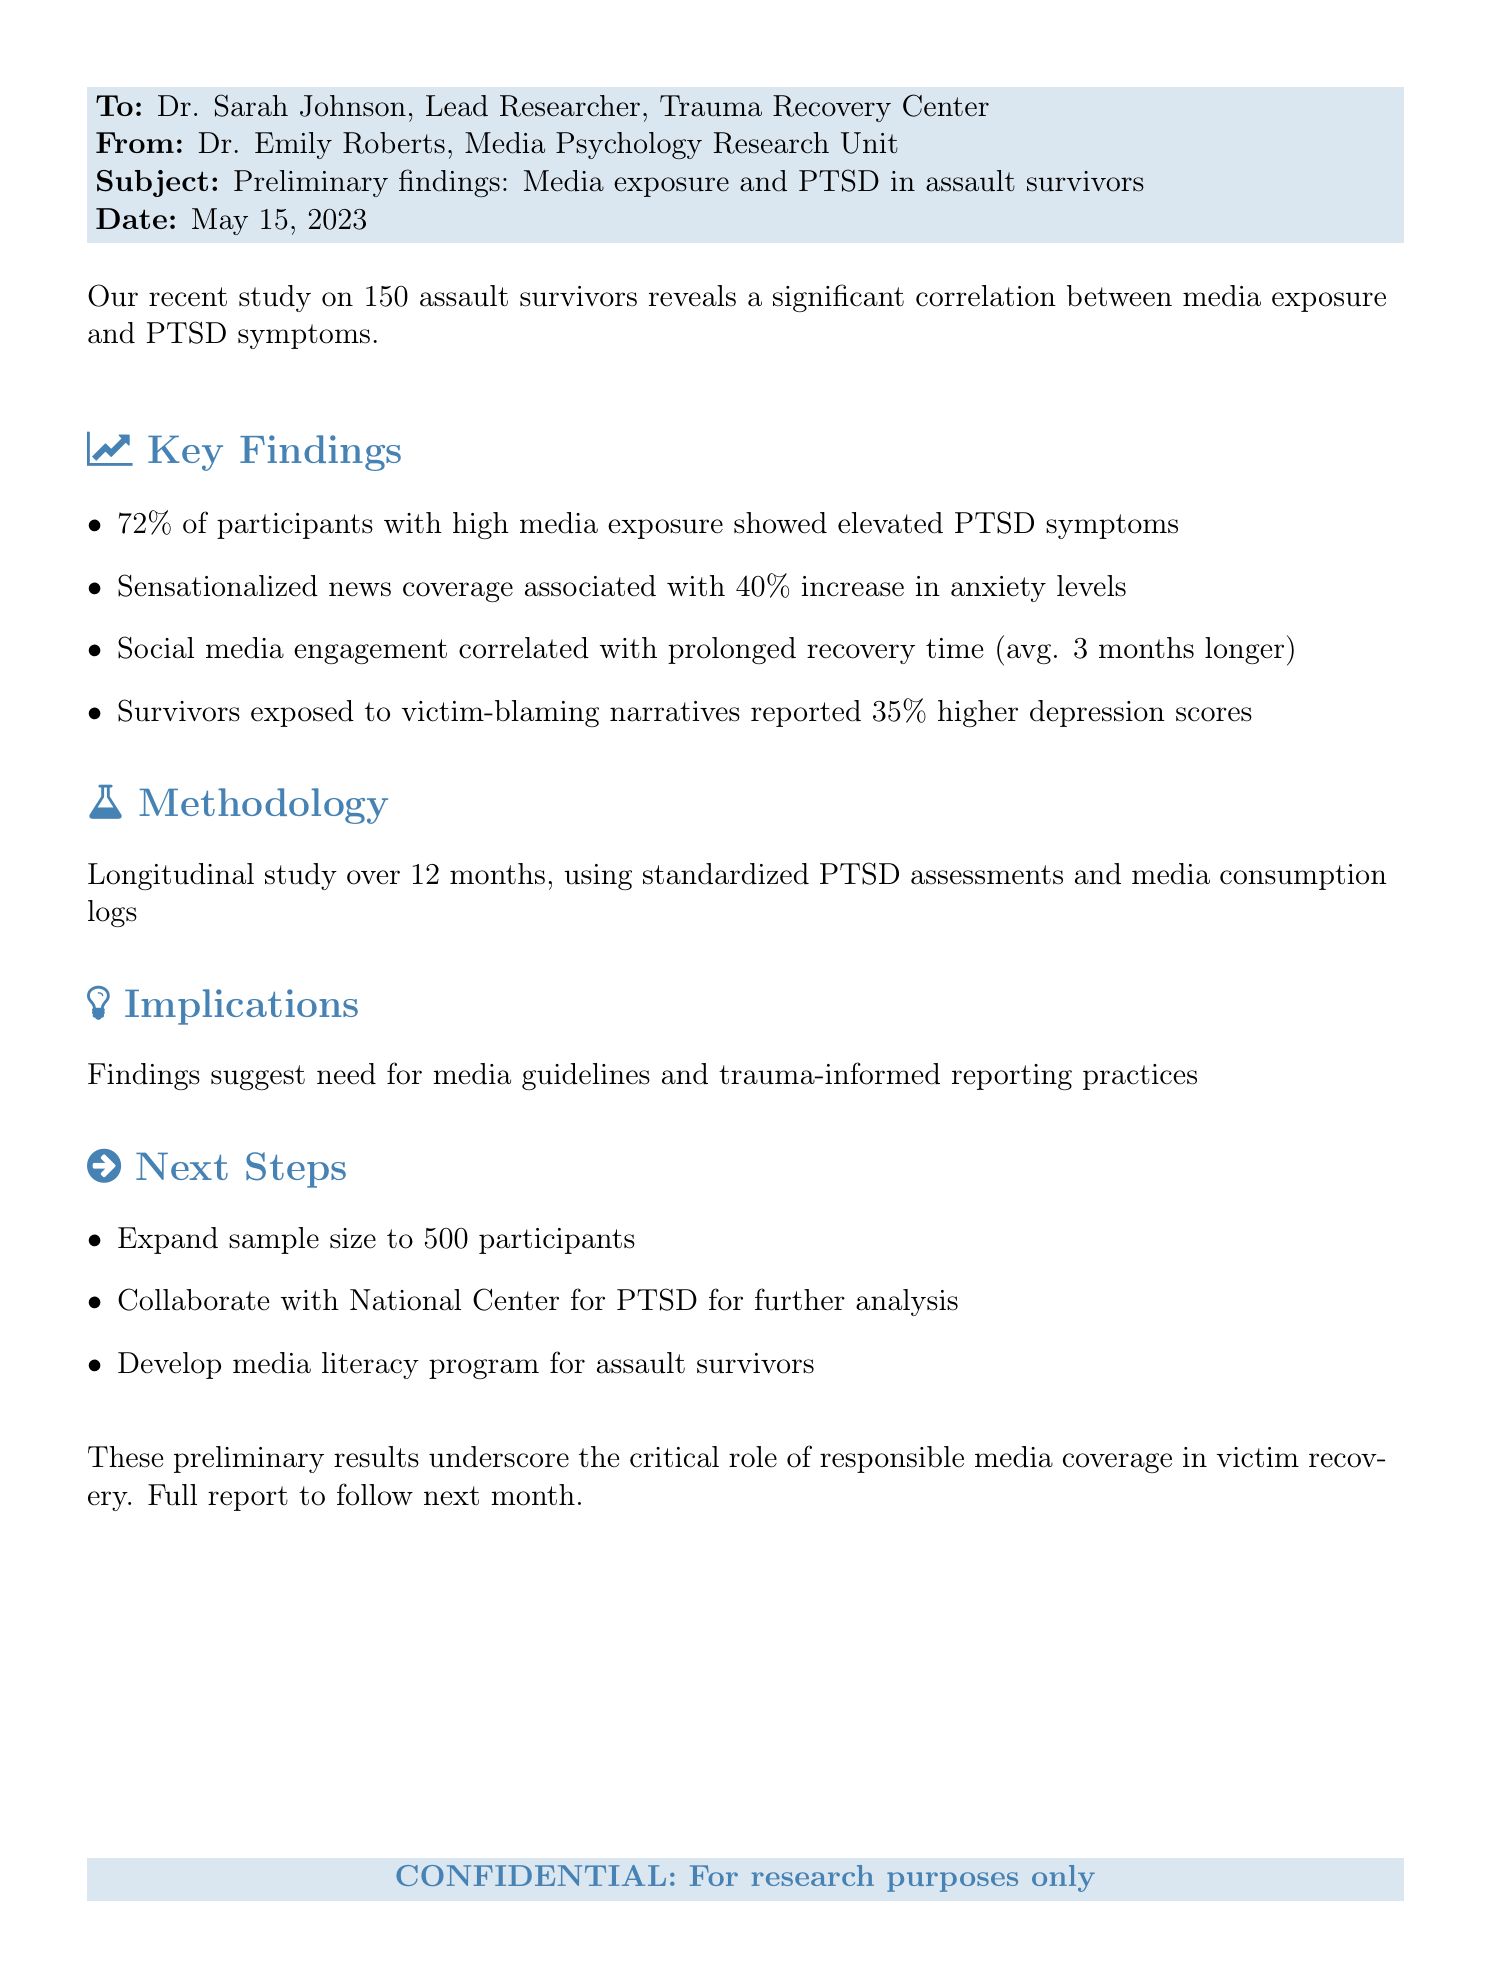What is the percentage of participants with high media exposure showing elevated PTSD symptoms? The document states that 72% of participants with high media exposure showed elevated PTSD symptoms.
Answer: 72% What increase in anxiety levels is associated with sensationalized news coverage? The document mentions that sensationalized news coverage is associated with a 40% increase in anxiety levels.
Answer: 40% What is the average prolongation of recovery time due to social media engagement? The average prolongation of recovery time due to social media engagement is stated as 3 months longer in the document.
Answer: 3 months What percentage higher are depression scores for survivors exposed to victim-blaming narratives? The document indicates that survivors exposed to victim-blaming narratives reported 35% higher depression scores.
Answer: 35% How many participants were included in the study? According to the document, the study included a total of 150 assault survivors.
Answer: 150 What is one of the next steps mentioned for the research? The document notes that one of the next steps includes expanding the sample size to 500 participants.
Answer: Expand sample size to 500 participants What type of study was conducted for this research? The document describes the methodology as a longitudinal study over 12 months.
Answer: Longitudinal study Who is the recipient of the fax? The recipient of the fax is Dr. Sarah Johnson, the Lead Researcher at the Trauma Recovery Center.
Answer: Dr. Sarah Johnson What date was the document sent? The date mentioned in the document for when the fax was sent is May 15, 2023.
Answer: May 15, 2023 